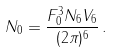<formula> <loc_0><loc_0><loc_500><loc_500>N _ { 0 } = \frac { F _ { 0 } ^ { 3 } N _ { 6 } V _ { 6 } } { ( 2 \pi ) ^ { 6 } } \, .</formula> 